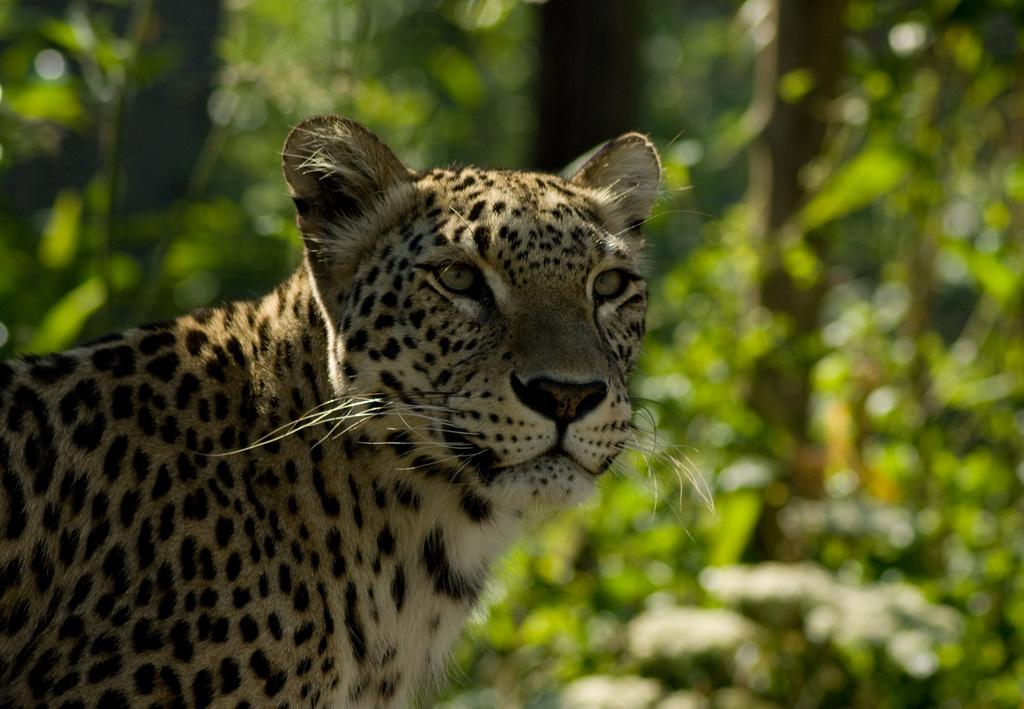What type of animal is in the image? There is a leopard in the image. What type of vegetation is visible in the image? There are trees in the image. How would you describe the background of the image? The background of the image is blurry. What type of locket is the leopard wearing in the image? There is no locket present on the leopard in the image. Can you see a plane flying in the background of the image? There is no plane visible in the background of the image. 